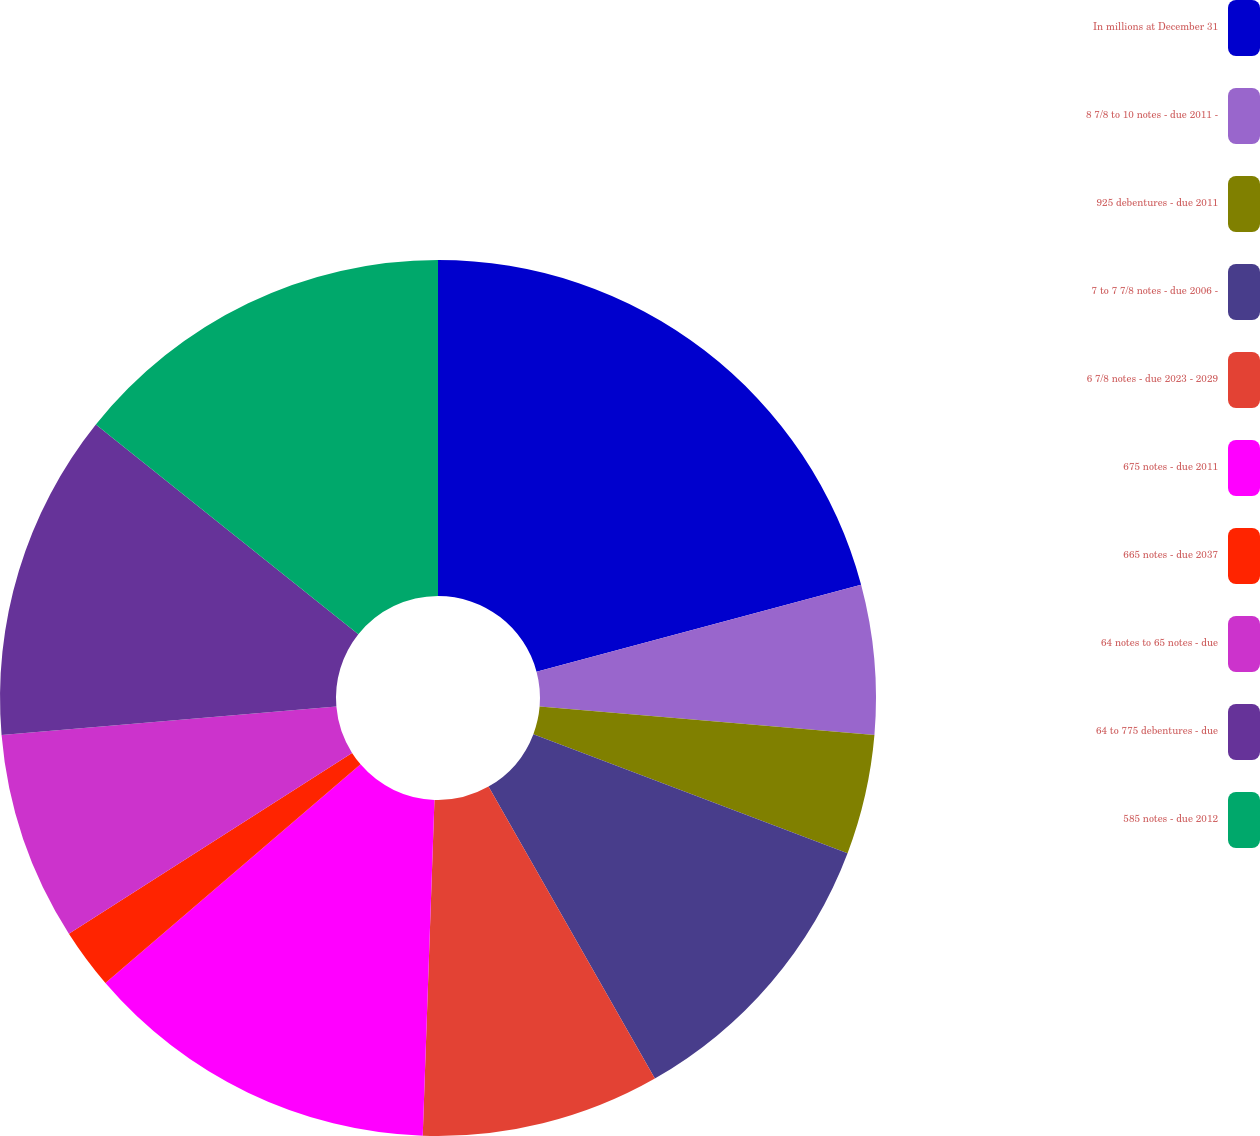Convert chart. <chart><loc_0><loc_0><loc_500><loc_500><pie_chart><fcel>In millions at December 31<fcel>8 7/8 to 10 notes - due 2011 -<fcel>925 debentures - due 2011<fcel>7 to 7 7/8 notes - due 2006 -<fcel>6 7/8 notes - due 2023 - 2029<fcel>675 notes - due 2011<fcel>665 notes - due 2037<fcel>64 notes to 65 notes - due<fcel>64 to 775 debentures - due<fcel>585 notes - due 2012<nl><fcel>20.84%<fcel>5.51%<fcel>4.42%<fcel>10.99%<fcel>8.8%<fcel>13.17%<fcel>2.23%<fcel>7.7%<fcel>12.08%<fcel>14.27%<nl></chart> 